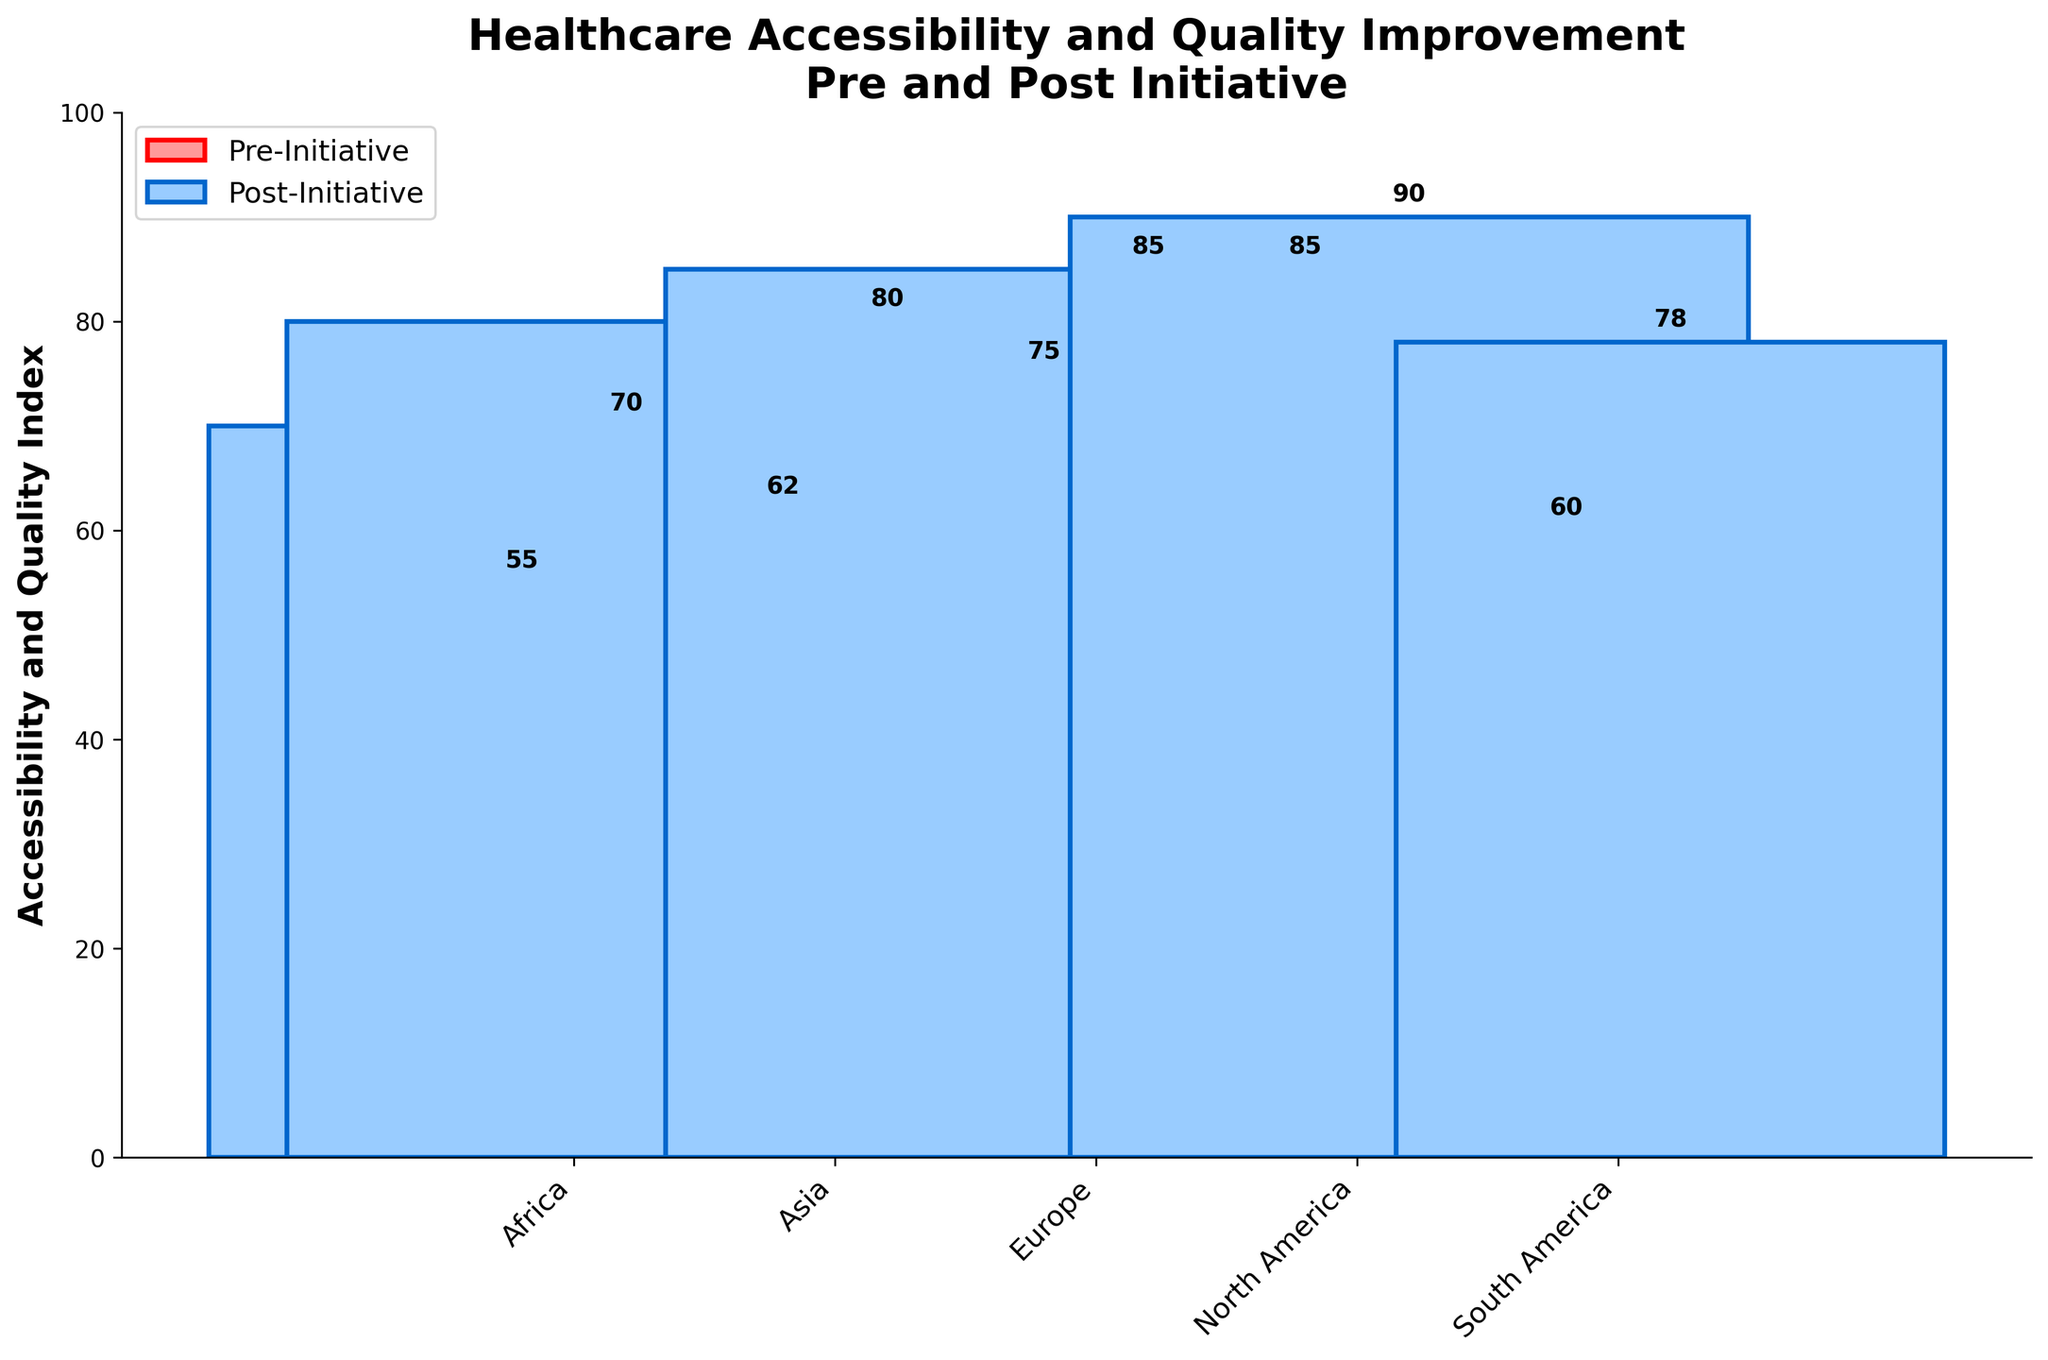What's the title of the plot? The title can be found at the top of the figure. It is written in a bold, large font. The title should provide an overview of what the figure is about.
Answer: Healthcare Accessibility and Quality Improvement Pre and Post Initiative Which region has the highest "Accessibility and Quality Index" post-initiative? By looking at the heights of the bars in the plot, the highest post-initiative value can be identified. It is the tallest blue bar.
Answer: North America What are the "Accessibility and Quality Index" values for Africa both pre- and post-initiative? Locate Africa on the x-axis, then check the heights of the red and blue bars associated with Africa along the y-axis. The red bar is pre-initiative, and the blue bar is post-initiative.
Answer: Pre-Initiative: 55, Post-Initiative: 70 Which region had the most significant improvement in "Accessibility and Quality Index" after the initiative? Calculate the difference between post-initiative and pre-initiative values for each region by subtracting the height of the red bar from the height of the blue bar. Identify the region with the largest difference.
Answer: Asia How does the population affecting each region influence the width of the post-initiative bars? The width of post-initiative bars corresponds to the population affecting the regions, scaled down as stated in the code. Regions with larger populations will have wider bars.
Answer: Higher population, wider bars What's the difference in the "Accessibility and Quality Index" for South America from 2016 to 2018? Find South America on the x-axis and note the heights of the red (2016) and blue (2018) bars. Subtract the pre-initiative value from the post-initiative value for South America.
Answer: 18 What is the approximate average "Accessibility and Quality Index" for all regions in 2018 (post-initiative)? Add the post-initiative values (blue bars) for all regions and divide by the number of regions (5). The post-initiative values are: 70 + 80 + 85 + 90 + 78. The sum is 403. Divide by 5.
Answer: 80.6 Did any region have the same "Accessibility and Quality Index" pre- and post-initiative? Compare each region's pre- and post-initiative values in the graph. Only consider cases where heights of both red and blue bars are equal.
Answer: No Which region had the smallest change in "Accessibility and Quality Index" from pre- to post-initiative? Calculate the difference in index value for each region by comparing pre- and post-initiative values, and find the smallest difference.
Answer: Europe What's the total population affected by the initiative across all regions in 2018? Sum the populations listed for each region in 2018, which are found in the code or source data: 3200000 + 4600000 + 3700000 + 2600000 + 2100000. The sum is 16200000.
Answer: 16,200,000 